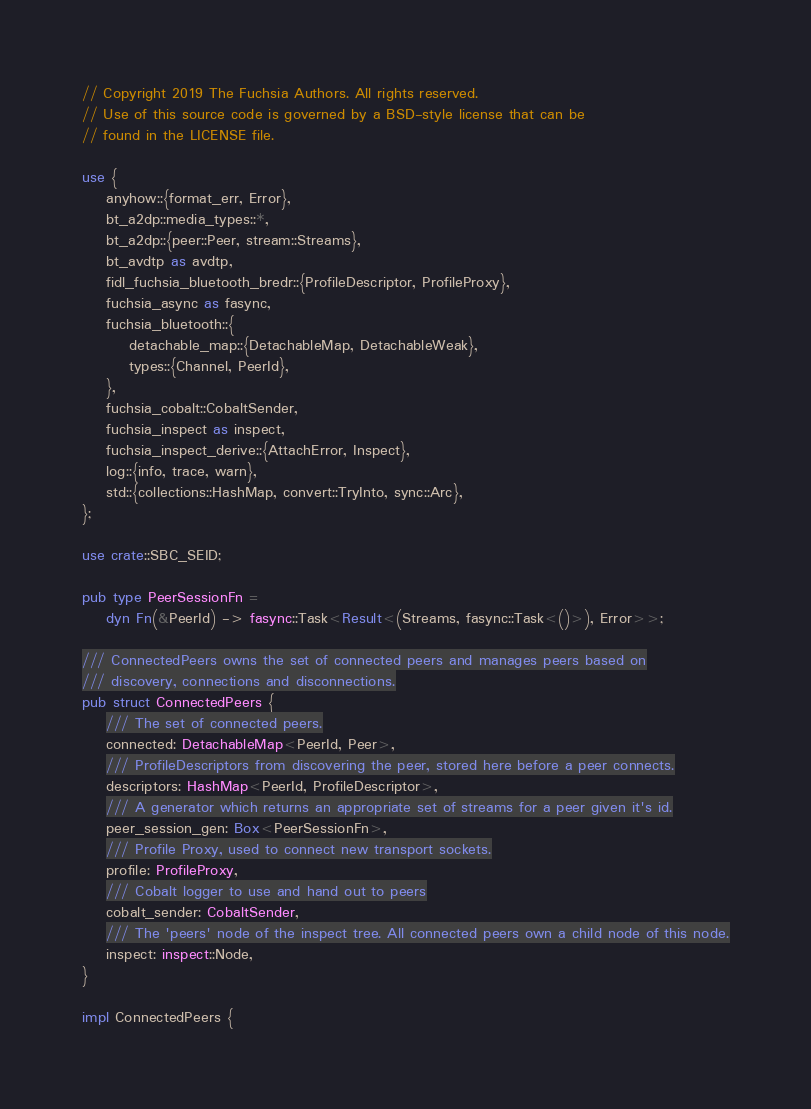<code> <loc_0><loc_0><loc_500><loc_500><_Rust_>// Copyright 2019 The Fuchsia Authors. All rights reserved.
// Use of this source code is governed by a BSD-style license that can be
// found in the LICENSE file.

use {
    anyhow::{format_err, Error},
    bt_a2dp::media_types::*,
    bt_a2dp::{peer::Peer, stream::Streams},
    bt_avdtp as avdtp,
    fidl_fuchsia_bluetooth_bredr::{ProfileDescriptor, ProfileProxy},
    fuchsia_async as fasync,
    fuchsia_bluetooth::{
        detachable_map::{DetachableMap, DetachableWeak},
        types::{Channel, PeerId},
    },
    fuchsia_cobalt::CobaltSender,
    fuchsia_inspect as inspect,
    fuchsia_inspect_derive::{AttachError, Inspect},
    log::{info, trace, warn},
    std::{collections::HashMap, convert::TryInto, sync::Arc},
};

use crate::SBC_SEID;

pub type PeerSessionFn =
    dyn Fn(&PeerId) -> fasync::Task<Result<(Streams, fasync::Task<()>), Error>>;

/// ConnectedPeers owns the set of connected peers and manages peers based on
/// discovery, connections and disconnections.
pub struct ConnectedPeers {
    /// The set of connected peers.
    connected: DetachableMap<PeerId, Peer>,
    /// ProfileDescriptors from discovering the peer, stored here before a peer connects.
    descriptors: HashMap<PeerId, ProfileDescriptor>,
    /// A generator which returns an appropriate set of streams for a peer given it's id.
    peer_session_gen: Box<PeerSessionFn>,
    /// Profile Proxy, used to connect new transport sockets.
    profile: ProfileProxy,
    /// Cobalt logger to use and hand out to peers
    cobalt_sender: CobaltSender,
    /// The 'peers' node of the inspect tree. All connected peers own a child node of this node.
    inspect: inspect::Node,
}

impl ConnectedPeers {</code> 